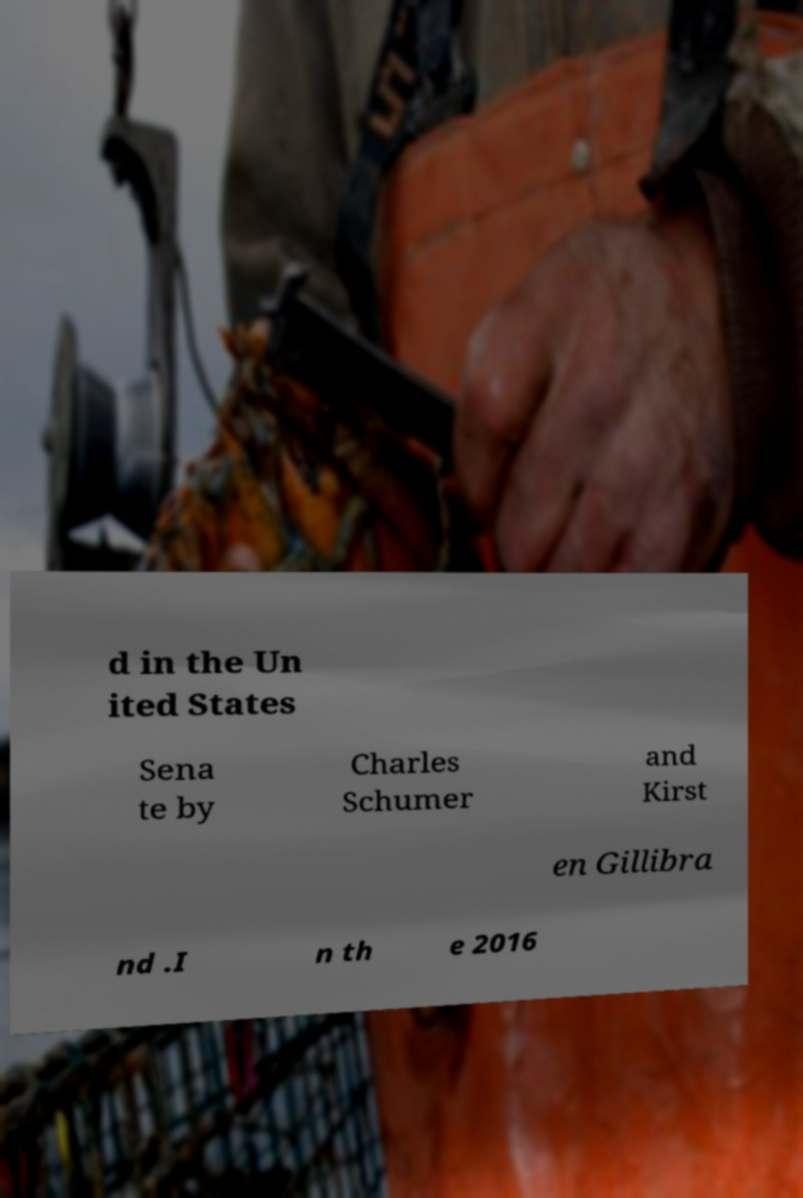Can you read and provide the text displayed in the image?This photo seems to have some interesting text. Can you extract and type it out for me? d in the Un ited States Sena te by Charles Schumer and Kirst en Gillibra nd .I n th e 2016 